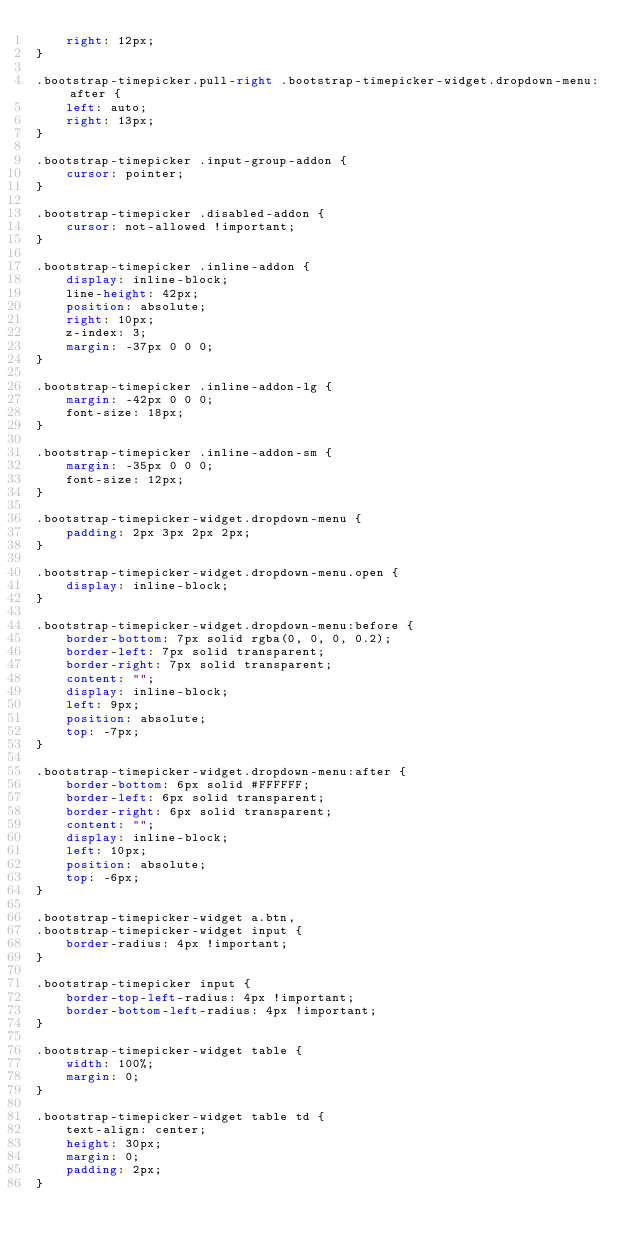Convert code to text. <code><loc_0><loc_0><loc_500><loc_500><_CSS_>    right: 12px;
}

.bootstrap-timepicker.pull-right .bootstrap-timepicker-widget.dropdown-menu:after {
    left: auto;
    right: 13px;
}

.bootstrap-timepicker .input-group-addon {
    cursor: pointer;
}

.bootstrap-timepicker .disabled-addon {
    cursor: not-allowed !important;
}

.bootstrap-timepicker .inline-addon {
    display: inline-block;
    line-height: 42px;
    position: absolute;
    right: 10px;
    z-index: 3;
    margin: -37px 0 0 0;
}

.bootstrap-timepicker .inline-addon-lg {
    margin: -42px 0 0 0;
    font-size: 18px;
}

.bootstrap-timepicker .inline-addon-sm {
    margin: -35px 0 0 0;
    font-size: 12px;
}

.bootstrap-timepicker-widget.dropdown-menu {
    padding: 2px 3px 2px 2px;
}

.bootstrap-timepicker-widget.dropdown-menu.open {
    display: inline-block;
}

.bootstrap-timepicker-widget.dropdown-menu:before {
    border-bottom: 7px solid rgba(0, 0, 0, 0.2);
    border-left: 7px solid transparent;
    border-right: 7px solid transparent;
    content: "";
    display: inline-block;
    left: 9px;
    position: absolute;
    top: -7px;
}

.bootstrap-timepicker-widget.dropdown-menu:after {
    border-bottom: 6px solid #FFFFFF;
    border-left: 6px solid transparent;
    border-right: 6px solid transparent;
    content: "";
    display: inline-block;
    left: 10px;
    position: absolute;
    top: -6px;
}

.bootstrap-timepicker-widget a.btn,
.bootstrap-timepicker-widget input {
    border-radius: 4px !important;
}

.bootstrap-timepicker input {
    border-top-left-radius: 4px !important;
    border-bottom-left-radius: 4px !important;
}

.bootstrap-timepicker-widget table {
    width: 100%;
    margin: 0;
}

.bootstrap-timepicker-widget table td {
    text-align: center;
    height: 30px;
    margin: 0;
    padding: 2px;
}
</code> 